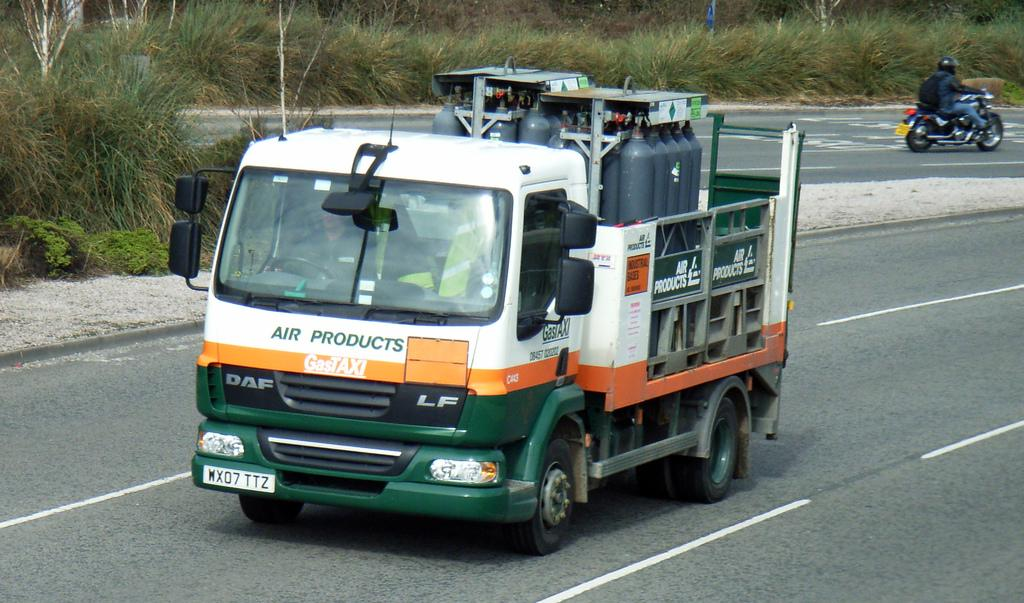What is happening in the image? There is a vehicle passing in the image. What is the setting of the image? There is a road in the image. What mode of transportation is also present? There is a bike in the image. What type of vegetation can be seen in the image? There is a plant and grass in the image. What type of terrain is visible in the image? There is sand in the image. What is the queen doing in the image? There is no queen present in the image. How many elbows can be seen in the image? Elbows are not visible in the image, as it features a vehicle, road, bike, plant, grass, and sand. 